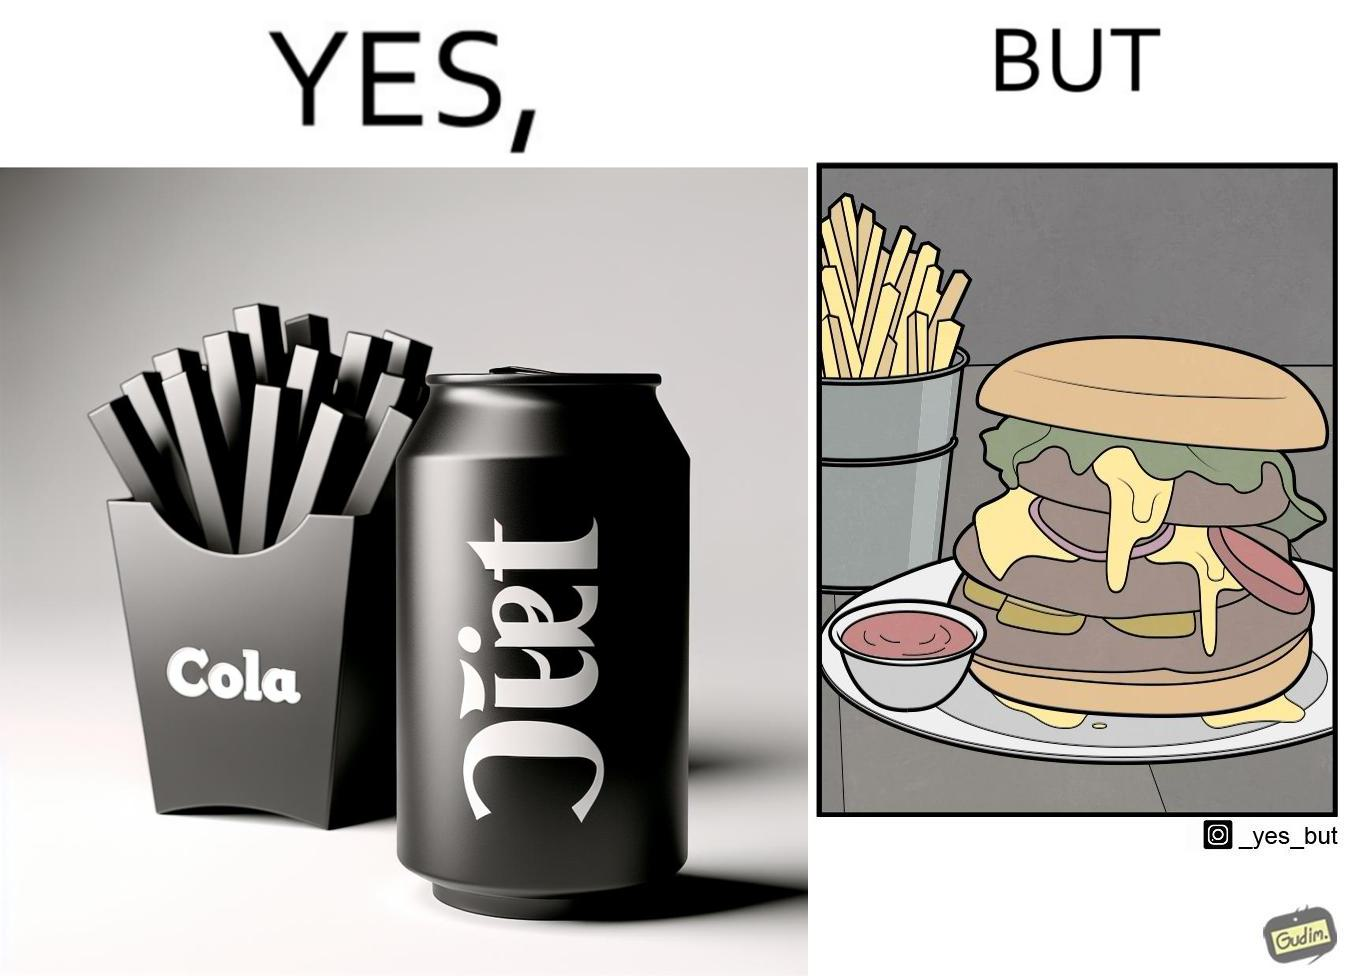Is this a satirical image? Yes, this image is satirical. 